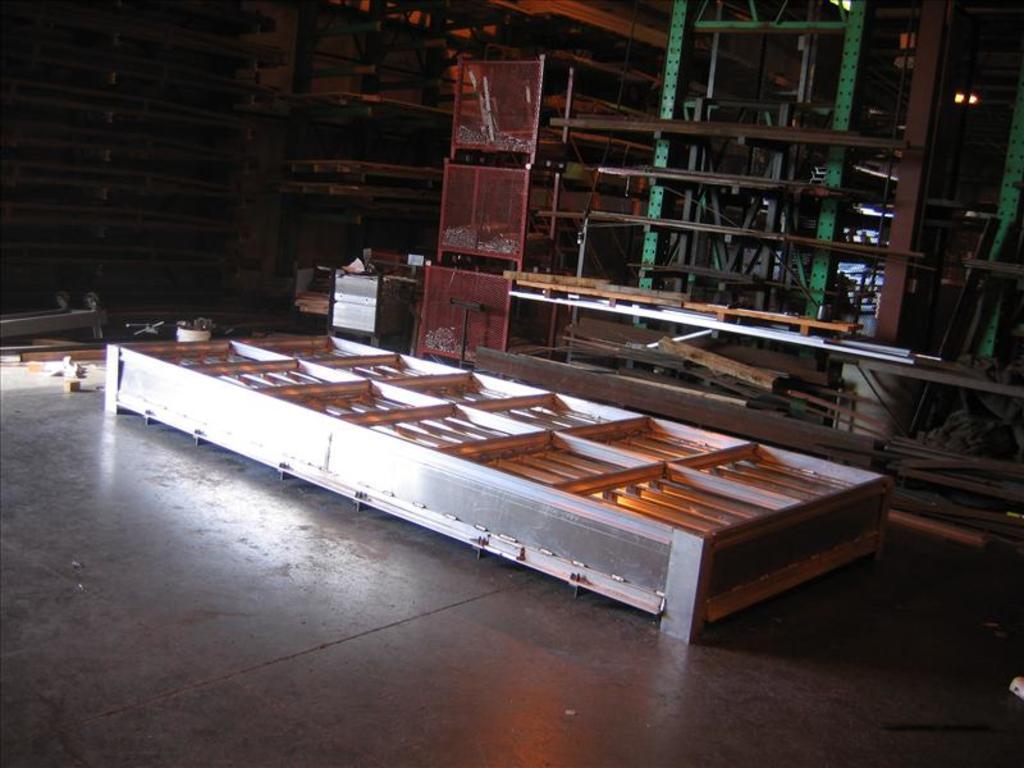Please provide a concise description of this image. In this picture, we can see the ground, and we can see some metallic objects and wooden objects on the ground. 